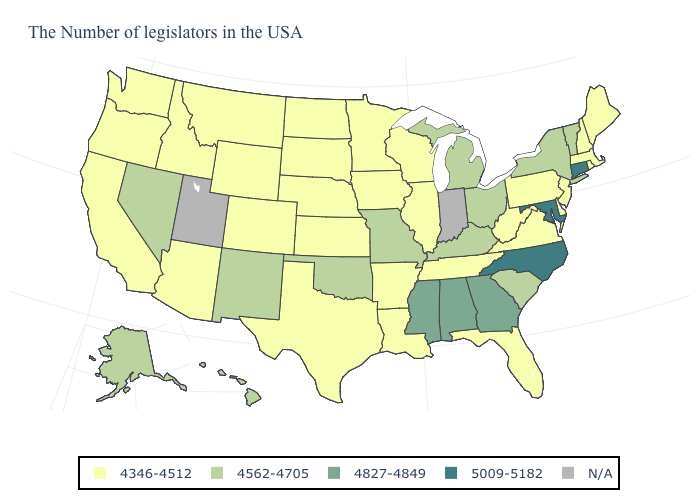What is the value of Alabama?
Answer briefly. 4827-4849. What is the value of Pennsylvania?
Answer briefly. 4346-4512. What is the value of Michigan?
Give a very brief answer. 4562-4705. Does the map have missing data?
Concise answer only. Yes. Is the legend a continuous bar?
Short answer required. No. Which states hav the highest value in the MidWest?
Be succinct. Ohio, Michigan, Missouri. Which states hav the highest value in the MidWest?
Short answer required. Ohio, Michigan, Missouri. What is the highest value in the Northeast ?
Keep it brief. 5009-5182. Name the states that have a value in the range 4827-4849?
Concise answer only. Georgia, Alabama, Mississippi. Among the states that border Missouri , does Kentucky have the lowest value?
Keep it brief. No. Name the states that have a value in the range 4562-4705?
Answer briefly. Vermont, New York, South Carolina, Ohio, Michigan, Kentucky, Missouri, Oklahoma, New Mexico, Nevada, Alaska, Hawaii. Does Connecticut have the highest value in the USA?
Short answer required. Yes. What is the value of Arkansas?
Give a very brief answer. 4346-4512. Does the map have missing data?
Short answer required. Yes. 